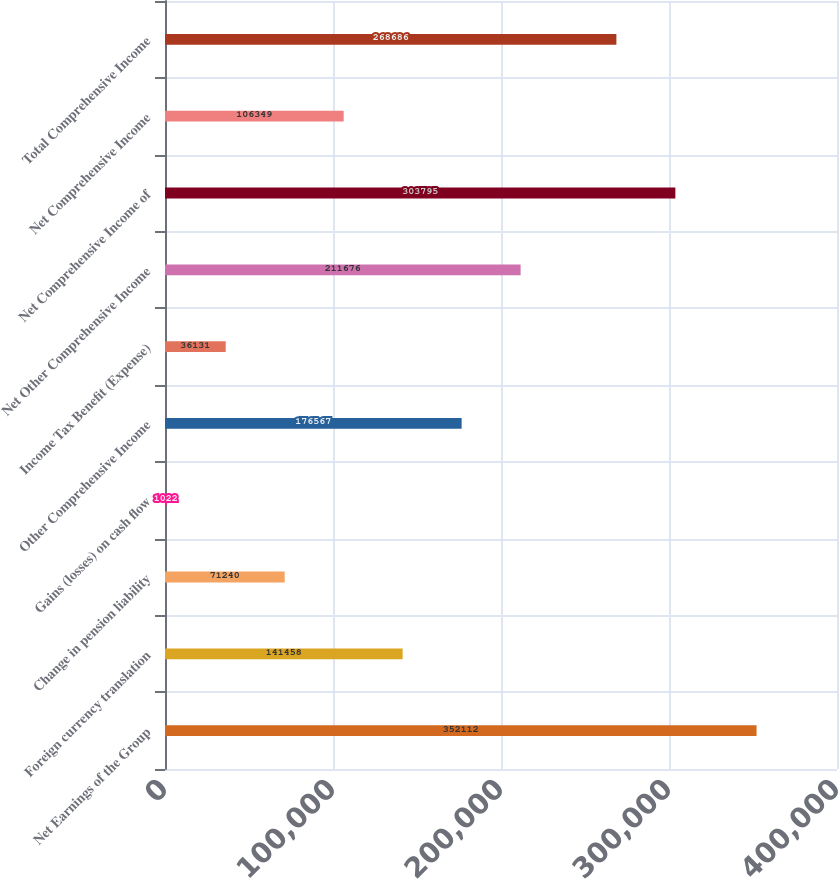Convert chart. <chart><loc_0><loc_0><loc_500><loc_500><bar_chart><fcel>Net Earnings of the Group<fcel>Foreign currency translation<fcel>Change in pension liability<fcel>Gains (losses) on cash flow<fcel>Other Comprehensive Income<fcel>Income Tax Benefit (Expense)<fcel>Net Other Comprehensive Income<fcel>Net Comprehensive Income of<fcel>Net Comprehensive Income<fcel>Total Comprehensive Income<nl><fcel>352112<fcel>141458<fcel>71240<fcel>1022<fcel>176567<fcel>36131<fcel>211676<fcel>303795<fcel>106349<fcel>268686<nl></chart> 